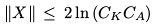<formula> <loc_0><loc_0><loc_500><loc_500>\| X \| \, \leq \, 2 \ln \left ( { C _ { K } C _ { A } } \right )</formula> 